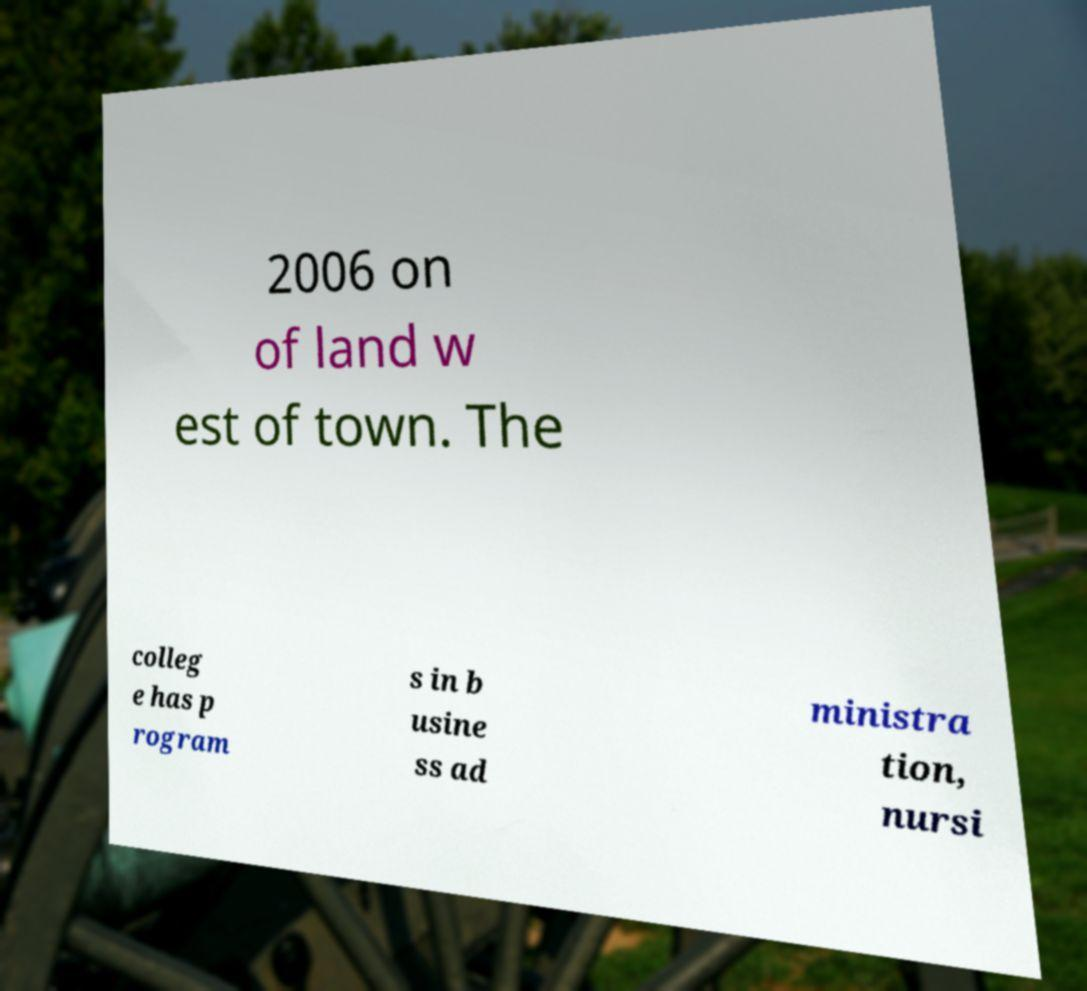Could you extract and type out the text from this image? 2006 on of land w est of town. The colleg e has p rogram s in b usine ss ad ministra tion, nursi 